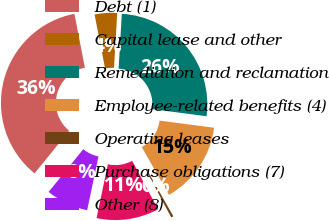Convert chart to OTSL. <chart><loc_0><loc_0><loc_500><loc_500><pie_chart><fcel>Debt (1)<fcel>Capital lease and other<fcel>Remediation and reclamation<fcel>Employee-related benefits (4)<fcel>Operating leases<fcel>Purchase obligations (7)<fcel>Other (8)<nl><fcel>36.09%<fcel>3.99%<fcel>26.14%<fcel>14.69%<fcel>0.42%<fcel>11.12%<fcel>7.55%<nl></chart> 